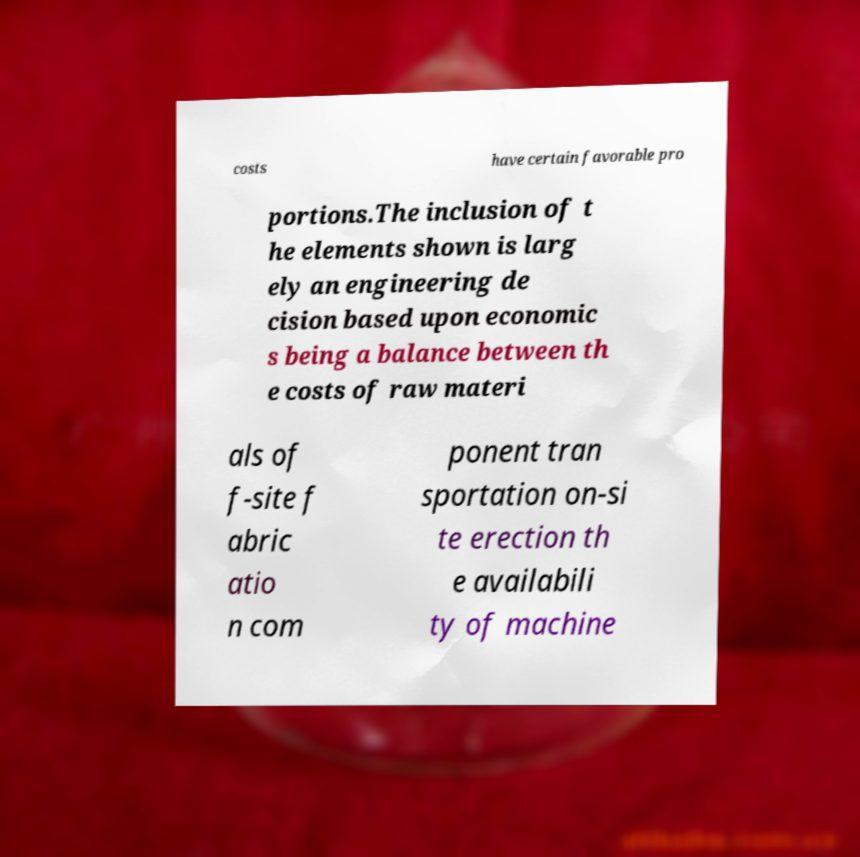Please identify and transcribe the text found in this image. costs have certain favorable pro portions.The inclusion of t he elements shown is larg ely an engineering de cision based upon economic s being a balance between th e costs of raw materi als of f-site f abric atio n com ponent tran sportation on-si te erection th e availabili ty of machine 